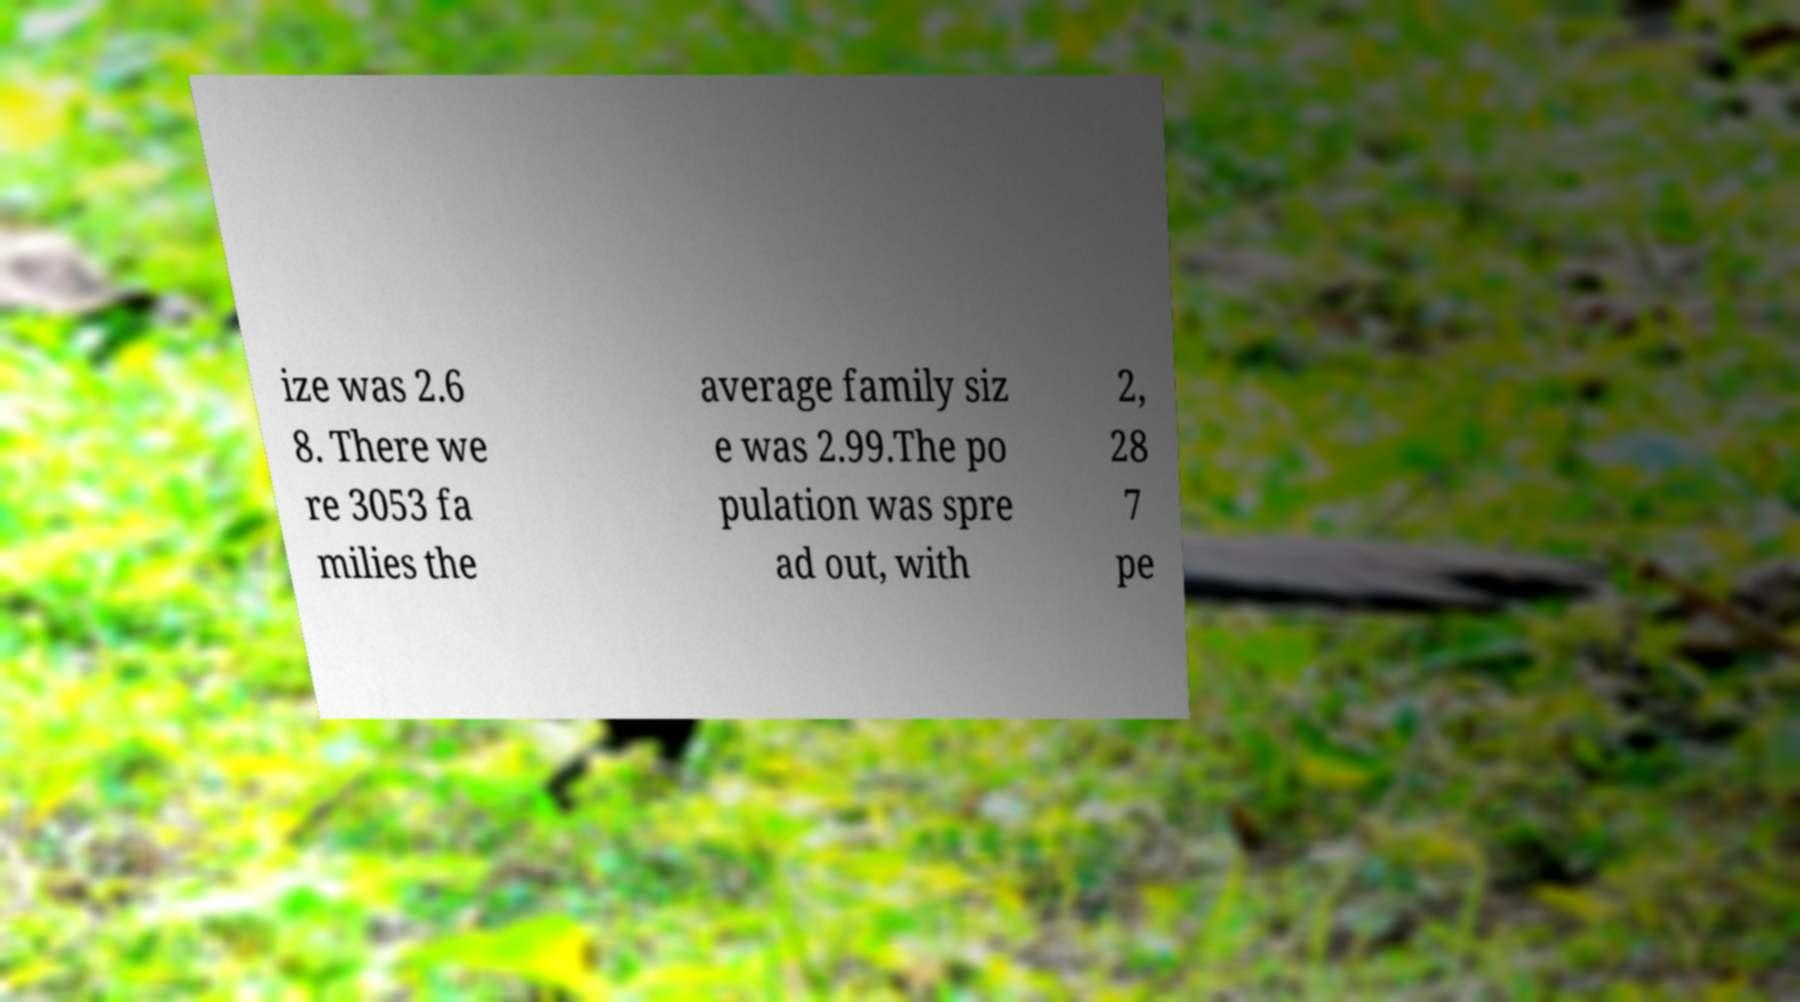Please identify and transcribe the text found in this image. ize was 2.6 8. There we re 3053 fa milies the average family siz e was 2.99.The po pulation was spre ad out, with 2, 28 7 pe 